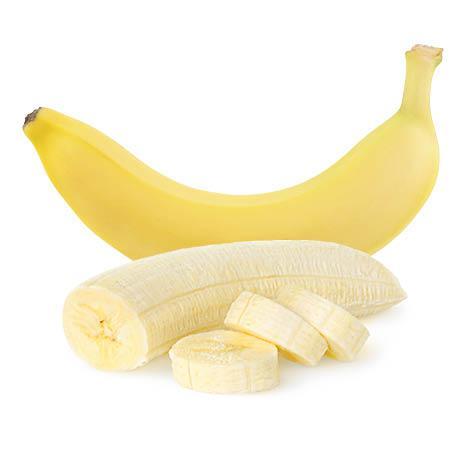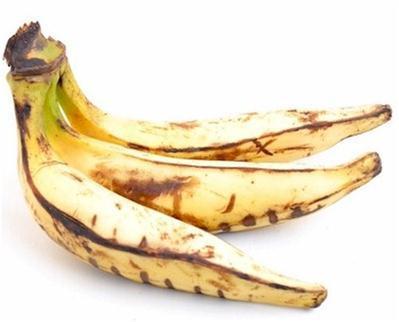The first image is the image on the left, the second image is the image on the right. Analyze the images presented: Is the assertion "In one of the images, at least part of a banana has been cut into slices." valid? Answer yes or no. Yes. The first image is the image on the left, the second image is the image on the right. For the images displayed, is the sentence "The left image contains a banana bunch with stems connected, and the right image includes at least part of an exposed, unpeeled banana." factually correct? Answer yes or no. No. 